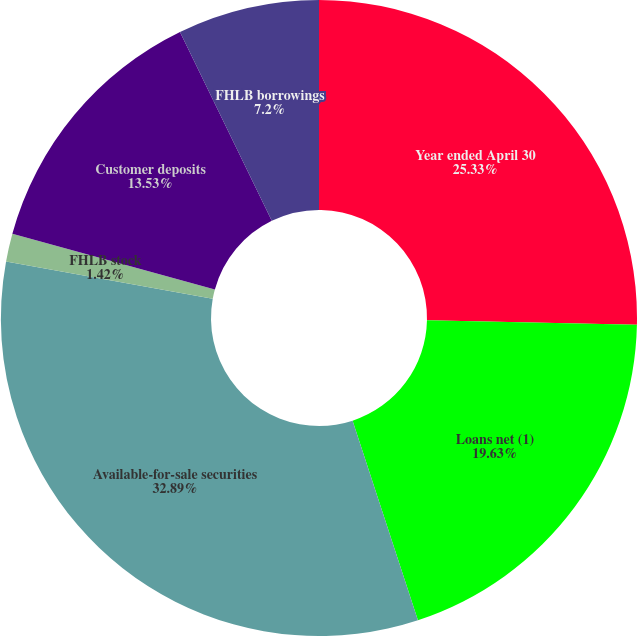Convert chart. <chart><loc_0><loc_0><loc_500><loc_500><pie_chart><fcel>Year ended April 30<fcel>Loans net (1)<fcel>Available-for-sale securities<fcel>FHLB stock<fcel>Customer deposits<fcel>FHLB borrowings<nl><fcel>25.33%<fcel>19.63%<fcel>32.88%<fcel>1.42%<fcel>13.53%<fcel>7.2%<nl></chart> 